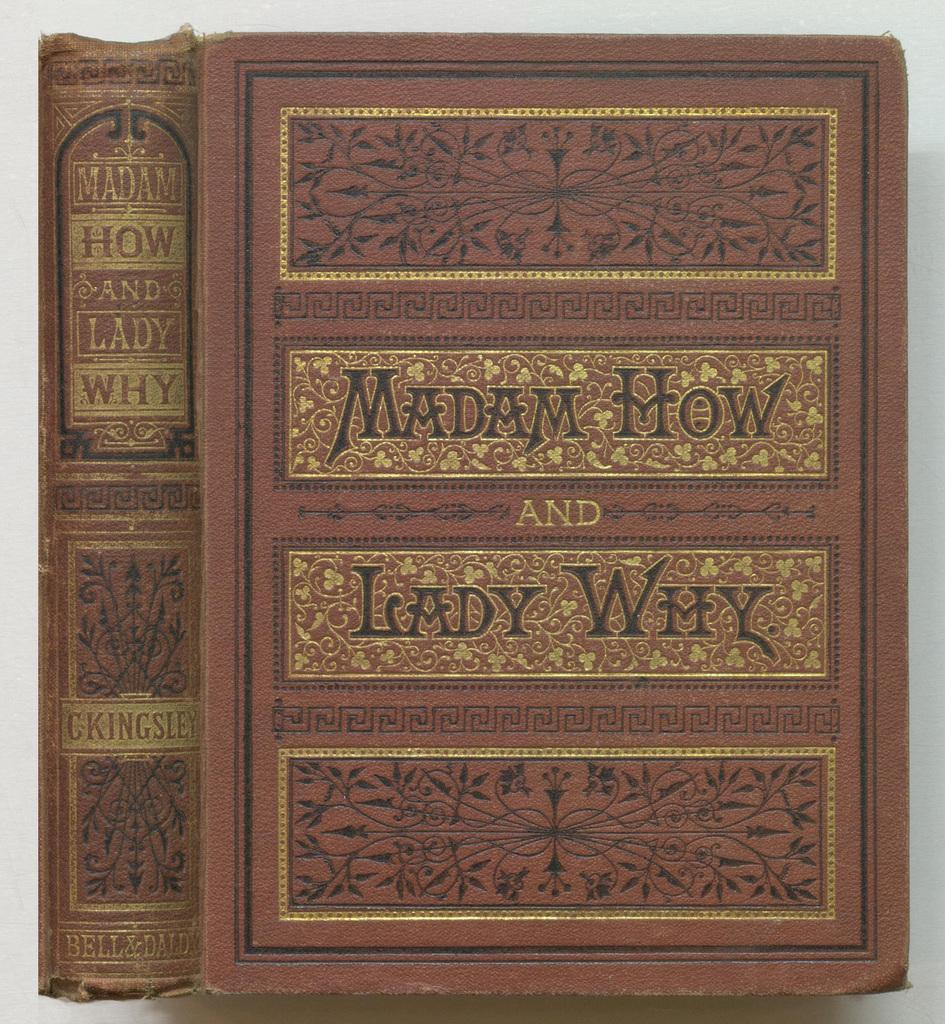What book is that?
Offer a terse response. Madam how and lady why. Who wrote this?
Provide a succinct answer. C kingsley. 